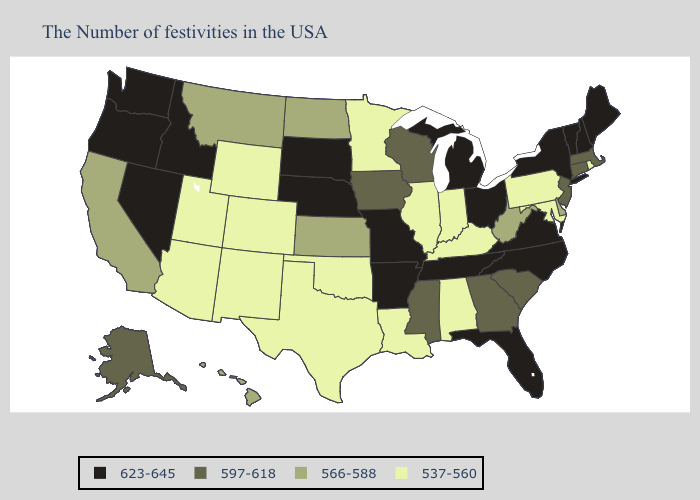What is the lowest value in states that border Iowa?
Give a very brief answer. 537-560. What is the highest value in the MidWest ?
Concise answer only. 623-645. Does Florida have the highest value in the South?
Concise answer only. Yes. Among the states that border Kansas , does Missouri have the highest value?
Concise answer only. Yes. Among the states that border Iowa , does Wisconsin have the highest value?
Give a very brief answer. No. Does Virginia have the lowest value in the USA?
Answer briefly. No. Does South Carolina have a higher value than Vermont?
Give a very brief answer. No. Does Louisiana have the highest value in the South?
Concise answer only. No. Does Maryland have a lower value than Nebraska?
Concise answer only. Yes. What is the value of North Carolina?
Concise answer only. 623-645. Name the states that have a value in the range 623-645?
Concise answer only. Maine, New Hampshire, Vermont, New York, Virginia, North Carolina, Ohio, Florida, Michigan, Tennessee, Missouri, Arkansas, Nebraska, South Dakota, Idaho, Nevada, Washington, Oregon. Which states hav the highest value in the South?
Give a very brief answer. Virginia, North Carolina, Florida, Tennessee, Arkansas. What is the value of Illinois?
Write a very short answer. 537-560. Is the legend a continuous bar?
Give a very brief answer. No. 